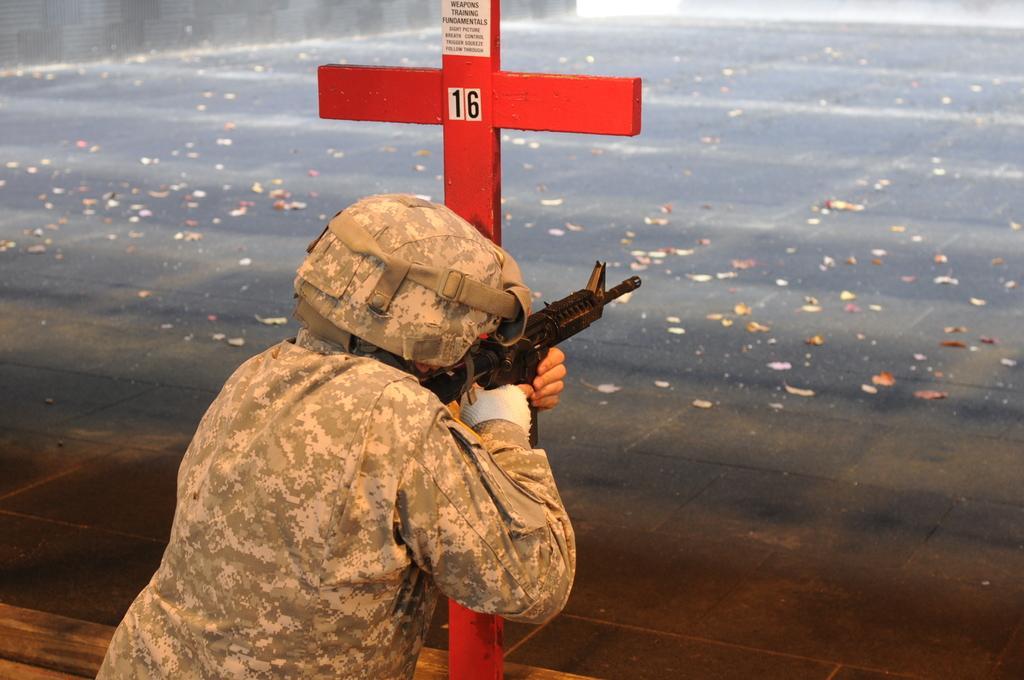Please provide a concise description of this image. Here in this picture we can see a person, who is wearing a military dress with helmet on him, holding a gun in his hand present over a place and in front of him we can see an Christianity symbol present over there and we can also see leaves present on the floor over there. 